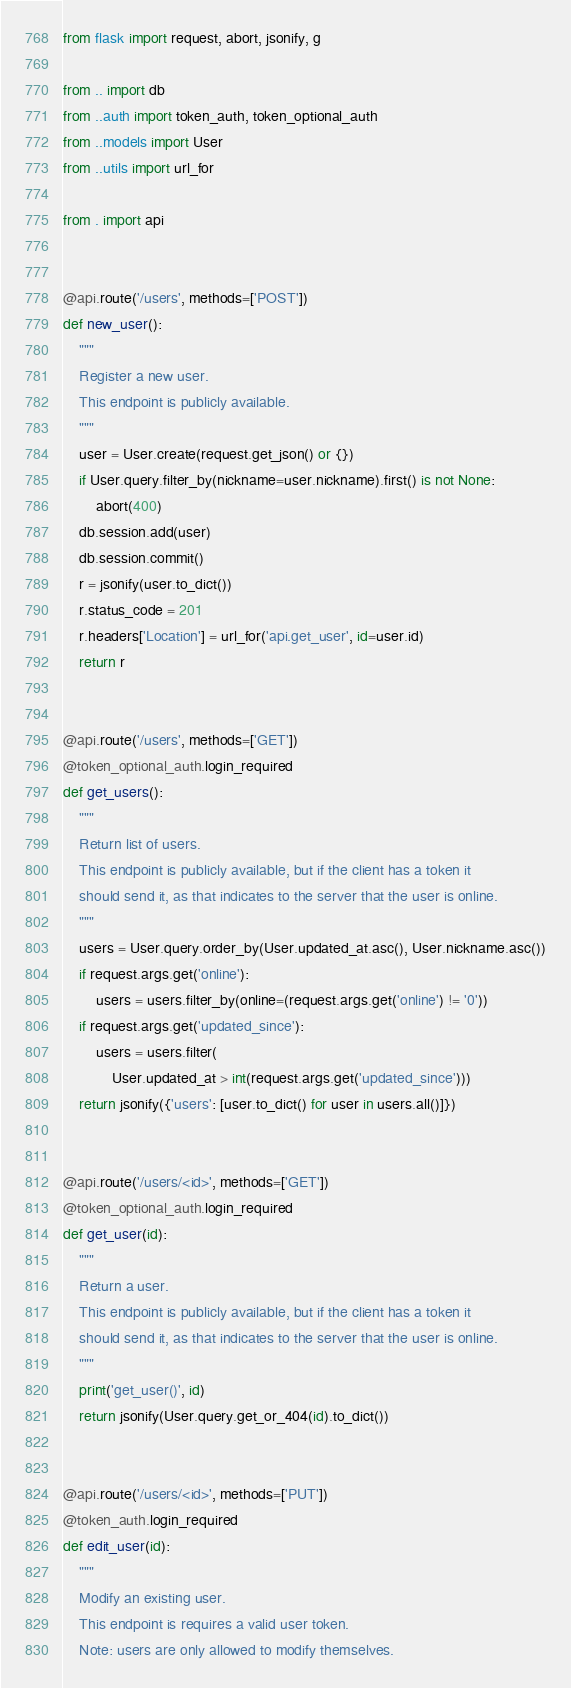Convert code to text. <code><loc_0><loc_0><loc_500><loc_500><_Python_>from flask import request, abort, jsonify, g

from .. import db
from ..auth import token_auth, token_optional_auth
from ..models import User
from ..utils import url_for

from . import api


@api.route('/users', methods=['POST'])
def new_user():
    """
    Register a new user.
    This endpoint is publicly available.
    """
    user = User.create(request.get_json() or {})
    if User.query.filter_by(nickname=user.nickname).first() is not None:
        abort(400)
    db.session.add(user)
    db.session.commit()
    r = jsonify(user.to_dict())
    r.status_code = 201
    r.headers['Location'] = url_for('api.get_user', id=user.id)
    return r


@api.route('/users', methods=['GET'])
@token_optional_auth.login_required
def get_users():
    """
    Return list of users.
    This endpoint is publicly available, but if the client has a token it
    should send it, as that indicates to the server that the user is online.
    """
    users = User.query.order_by(User.updated_at.asc(), User.nickname.asc())
    if request.args.get('online'):
        users = users.filter_by(online=(request.args.get('online') != '0'))
    if request.args.get('updated_since'):
        users = users.filter(
            User.updated_at > int(request.args.get('updated_since')))
    return jsonify({'users': [user.to_dict() for user in users.all()]})


@api.route('/users/<id>', methods=['GET'])
@token_optional_auth.login_required
def get_user(id):
    """
    Return a user.
    This endpoint is publicly available, but if the client has a token it
    should send it, as that indicates to the server that the user is online.
    """
    print('get_user()', id)
    return jsonify(User.query.get_or_404(id).to_dict())


@api.route('/users/<id>', methods=['PUT'])
@token_auth.login_required
def edit_user(id):
    """
    Modify an existing user.
    This endpoint is requires a valid user token.
    Note: users are only allowed to modify themselves.</code> 